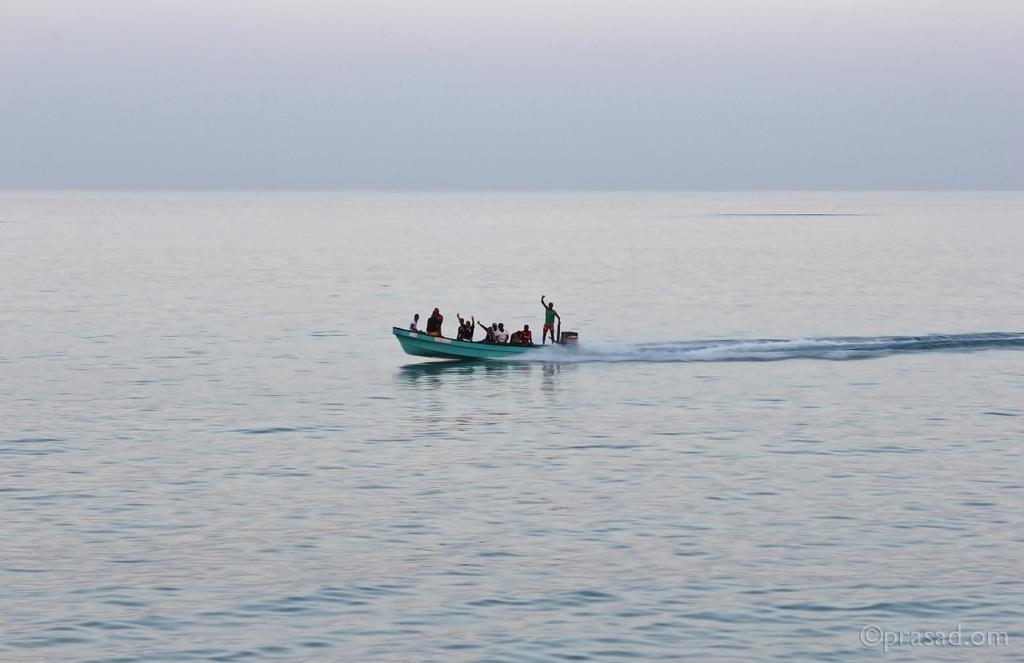What is the main subject of the image? The main subject of the image is people on a boat. What type of environment can be seen in the image? There is water visible in the image, suggesting a water-based environment. What else is visible in the image besides the boat and people? The sky is visible in the image. What type of soda can be seen floating in the water in the image? There is no soda visible in the image; only water is present. Can you tell me how many jellyfish are swimming near the boat in the image? There are no jellyfish visible in the image; only people on a boat and water are present. 